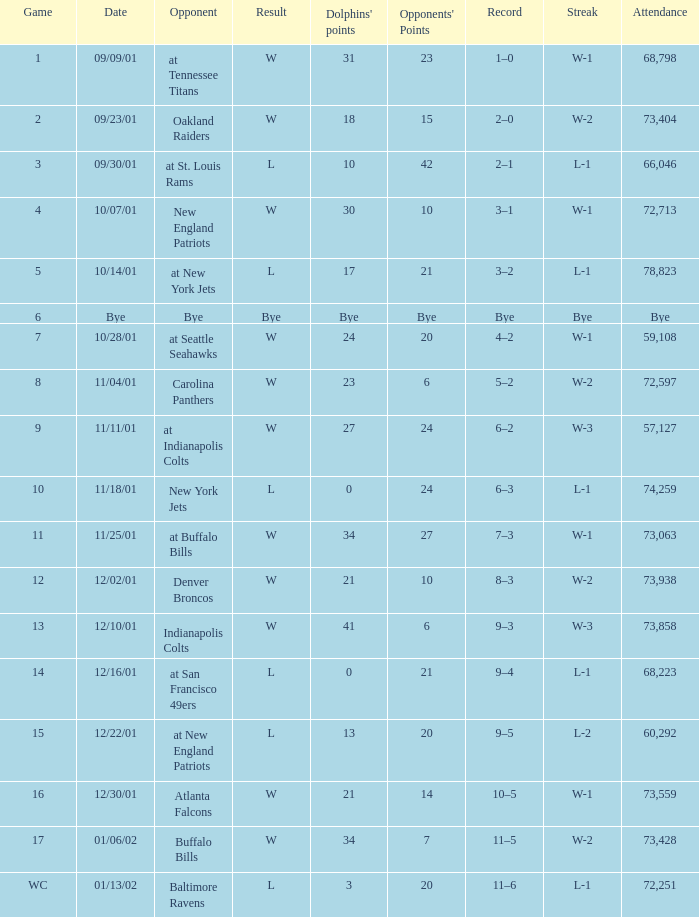What was the number of attendees when the game featured an opponent on a bye? Bye. 